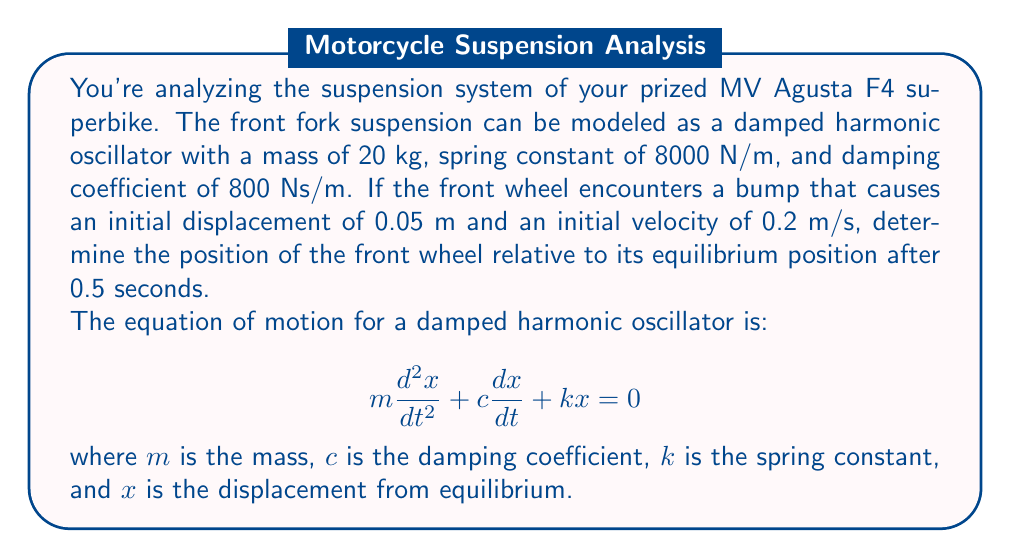Solve this math problem. To solve this problem, we'll follow these steps:

1) First, we need to calculate the angular frequency $\omega_0$ and the damping ratio $\zeta$:

   $\omega_0 = \sqrt{\frac{k}{m}} = \sqrt{\frac{8000}{20}} = 20$ rad/s

   $\zeta = \frac{c}{2m\omega_0} = \frac{800}{2(20)(20)} = 1$

2) Since $\zeta = 1$, this is a critically damped system. The general solution for a critically damped system is:

   $x(t) = e^{-\omega_0 t}(A + Bt)$

   where $A$ and $B$ are constants determined by initial conditions.

3) We can find $A$ and $B$ using the initial conditions:
   
   $x(0) = 0.05$ and $\frac{dx}{dt}(0) = 0.2$

4) Applying these conditions:

   $x(0) = A = 0.05$

   $\frac{dx}{dt}(0) = -\omega_0 A + B = 0.2$

   $B = 0.2 + \omega_0 A = 0.2 + 20(0.05) = 1.2$

5) Therefore, our solution is:

   $x(t) = e^{-20t}(0.05 + 1.2t)$

6) To find the position at $t = 0.5$ seconds, we simply substitute this value:

   $x(0.5) = e^{-20(0.5)}(0.05 + 1.2(0.5))$
           $= e^{-10}(0.05 + 0.6)$
           $= e^{-10}(0.65)$
           $\approx 0.00029$ m
Answer: The position of the front wheel relative to its equilibrium position after 0.5 seconds is approximately 0.00029 m or 0.29 mm. 